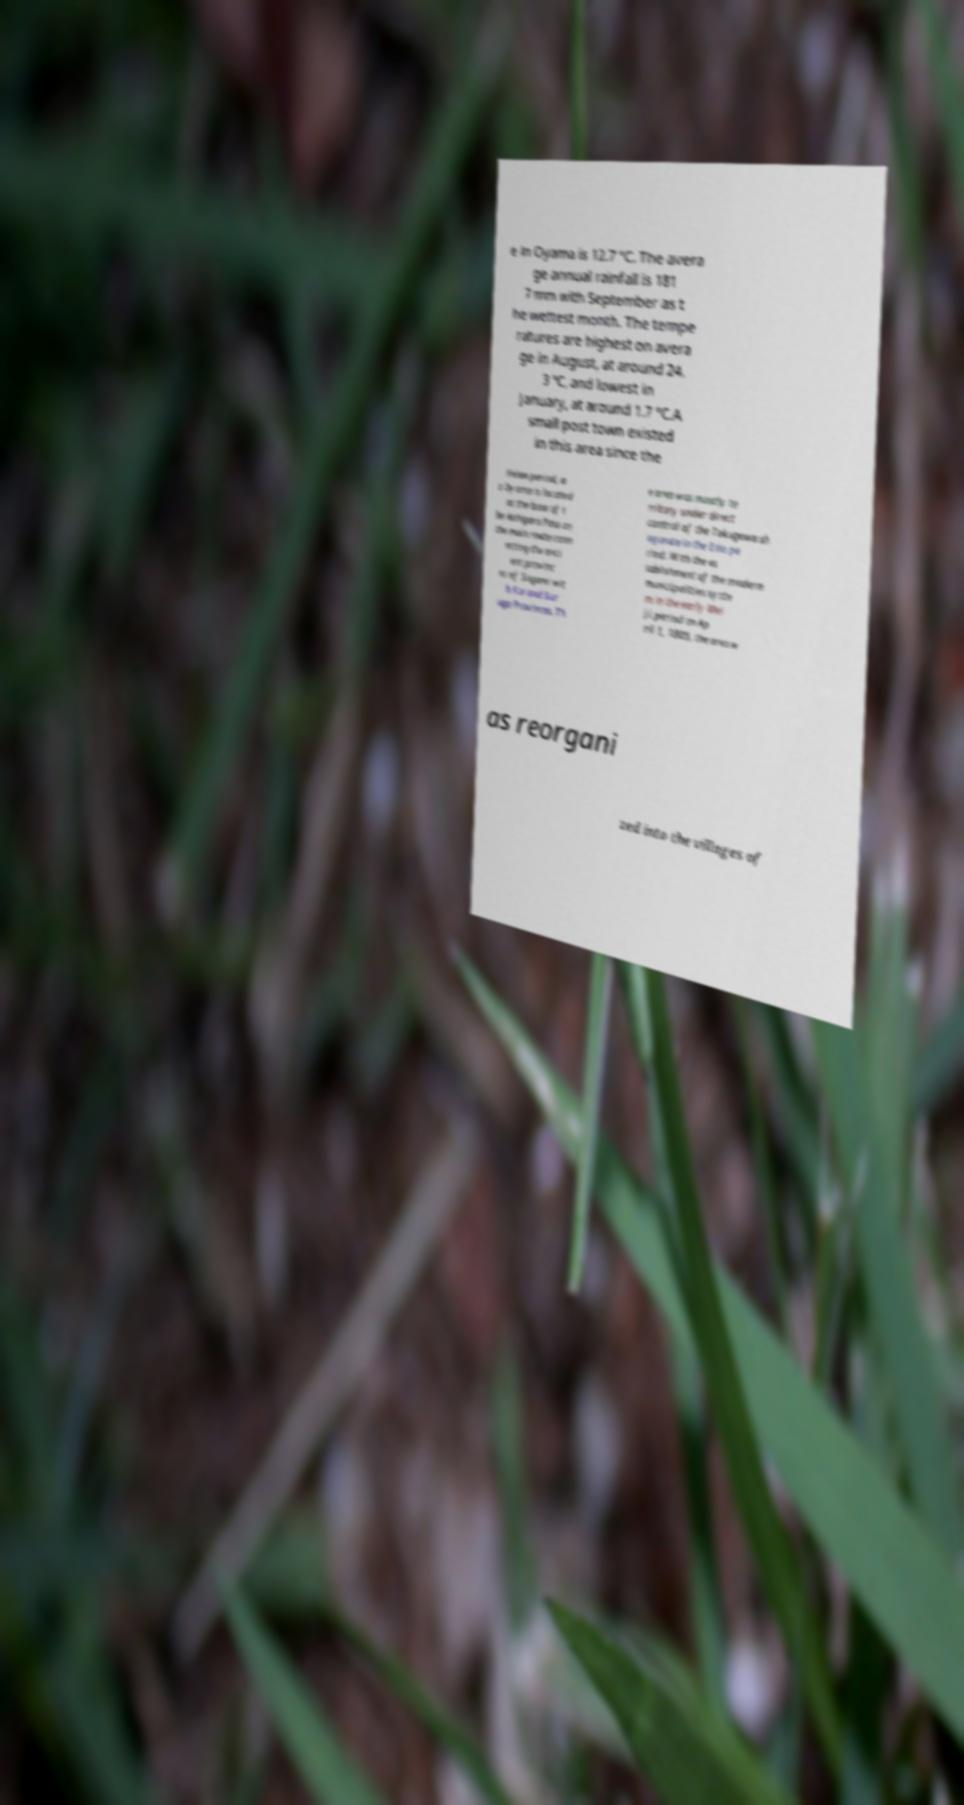I need the written content from this picture converted into text. Can you do that? e in Oyama is 12.7 °C. The avera ge annual rainfall is 181 7 mm with September as t he wettest month. The tempe ratures are highest on avera ge in August, at around 24. 3 °C, and lowest in January, at around 1.7 °C.A small post town existed in this area since the Heian period, a s Oyama is located at the base of t he Ashigara Pass on the main route conn ecting the anci ent provinc es of Sagami wit h Kai and Sur uga Provinces. Th e area was mostly te rritory under direct control of the Tokugawa sh ogunate in the Edo pe riod. With the es tablishment of the modern municipalities syste m in the early Mei ji period on Ap ril 1, 1889, the area w as reorgani zed into the villages of 